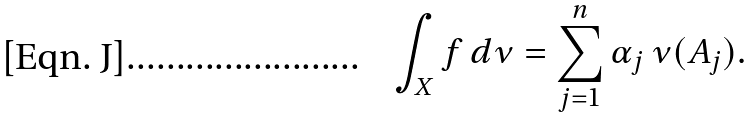Convert formula to latex. <formula><loc_0><loc_0><loc_500><loc_500>\int _ { X } f \, d \nu = \sum _ { j = 1 } ^ { n } \alpha _ { j } \, \nu ( A _ { j } ) .</formula> 